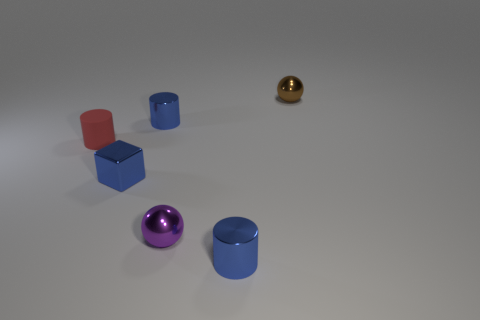Add 1 small blue cylinders. How many objects exist? 7 Subtract all blocks. How many objects are left? 5 Add 4 tiny matte cylinders. How many tiny matte cylinders are left? 5 Add 2 small cubes. How many small cubes exist? 3 Subtract 1 brown balls. How many objects are left? 5 Subtract all shiny spheres. Subtract all blue metallic cylinders. How many objects are left? 2 